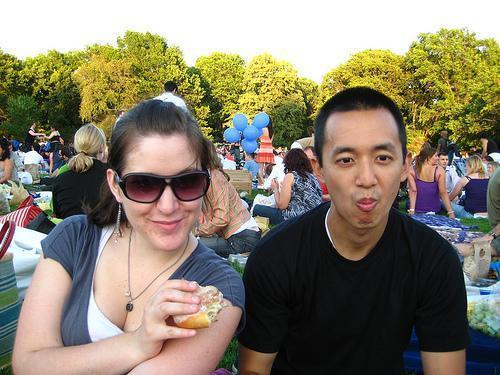How many balloons are in this picture?
Give a very brief answer. 5. How many people are there?
Give a very brief answer. 7. How many dogs are there?
Give a very brief answer. 0. 